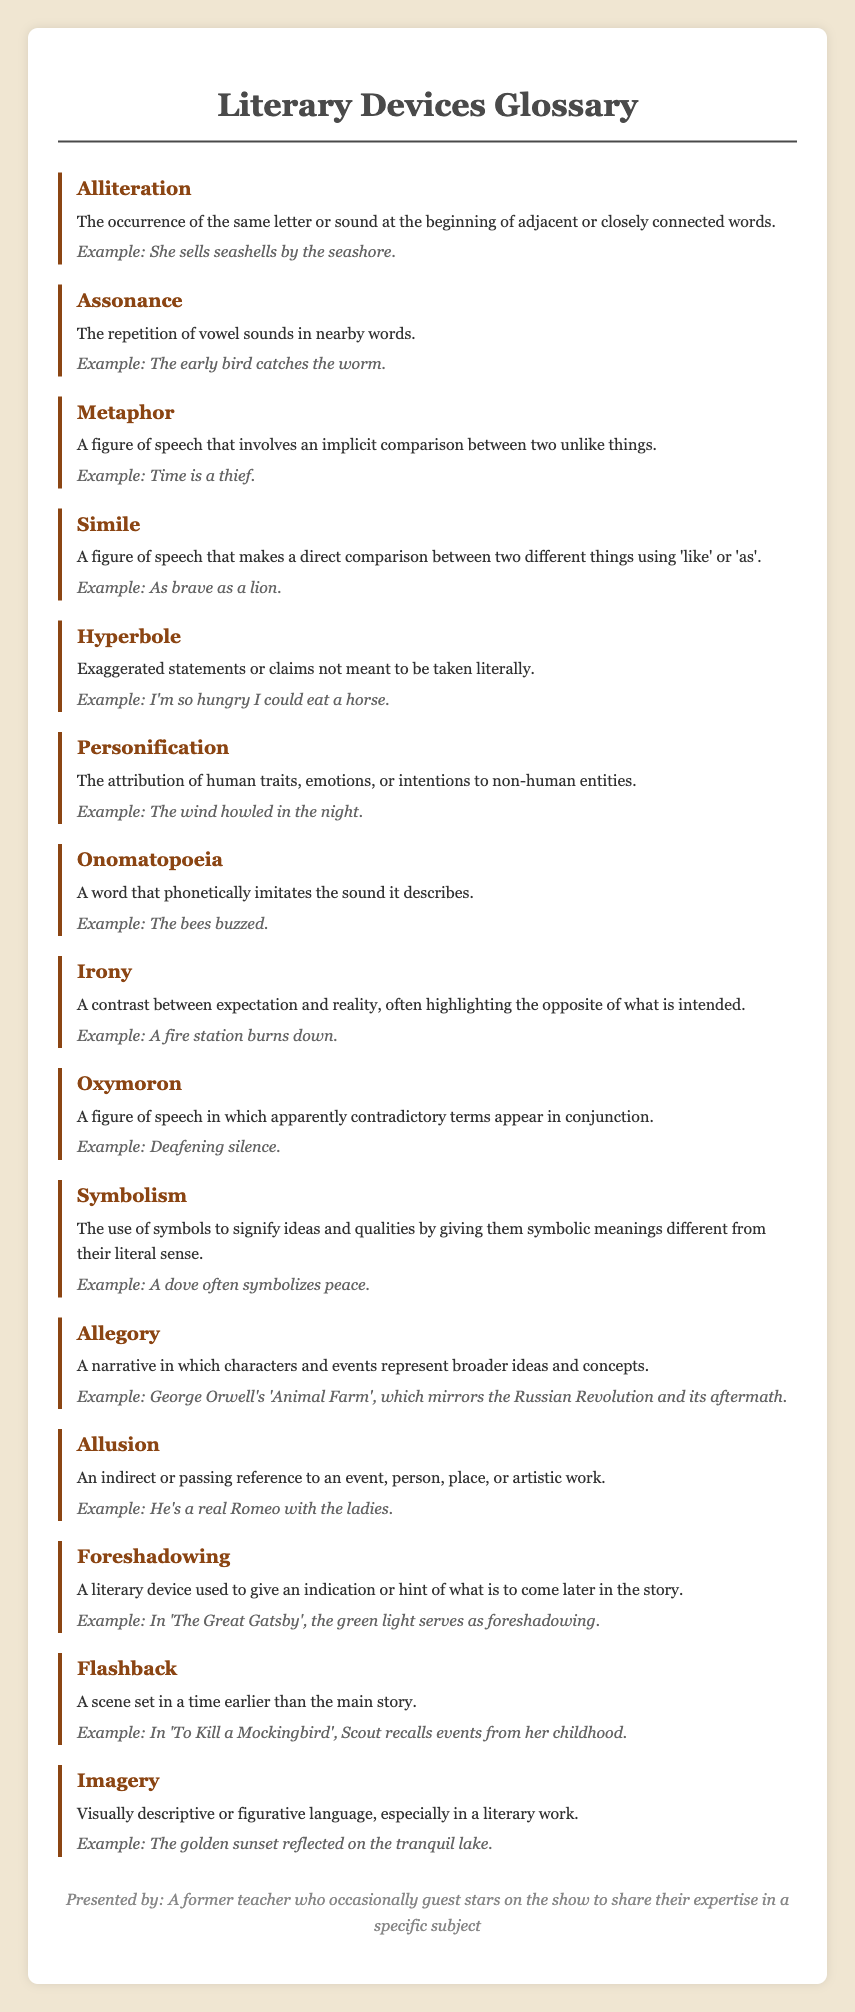what is the term for the repetition of vowel sounds in nearby words? The document defines 'Assonance' as the repetition of vowel sounds in nearby words.
Answer: Assonance what literary device involves an implicit comparison between two unlike things? The document describes 'Metaphor' as a figure of speech that involves an implicit comparison between two unlike things.
Answer: Metaphor what is an example of alliteration provided in the document? The document includes "She sells seashells by the seashore" as an example of alliteration.
Answer: She sells seashells by the seashore which literary device attributes human traits to non-human entities? The term that describes this as per the document is 'Personification'.
Answer: Personification how is 'foreshadowing' defined in the glossary? 'Foreshadowing' is defined as a literary device used to give an indication or hint of what is to come later in the story.
Answer: Indication or hint of what is to come later in the story what figure of speech makes a direct comparison using 'like' or 'as'? The document specifies that a 'Simile' makes a direct comparison between two different things using 'like' or 'as'.
Answer: Simile which device is described by an indirect reference to an event or person? The term for this is 'Allusion', as defined in the document.
Answer: Allusion what is a key characteristic of an allegory? An allegory represents broader ideas and concepts through characters and events, as mentioned in the document.
Answer: Represents broader ideas and concepts what is the main purpose of the literary device known as 'symbolism'? According to the document, symbolism is used to signify ideas and qualities by giving them symbolic meanings.
Answer: Signify ideas and qualities 